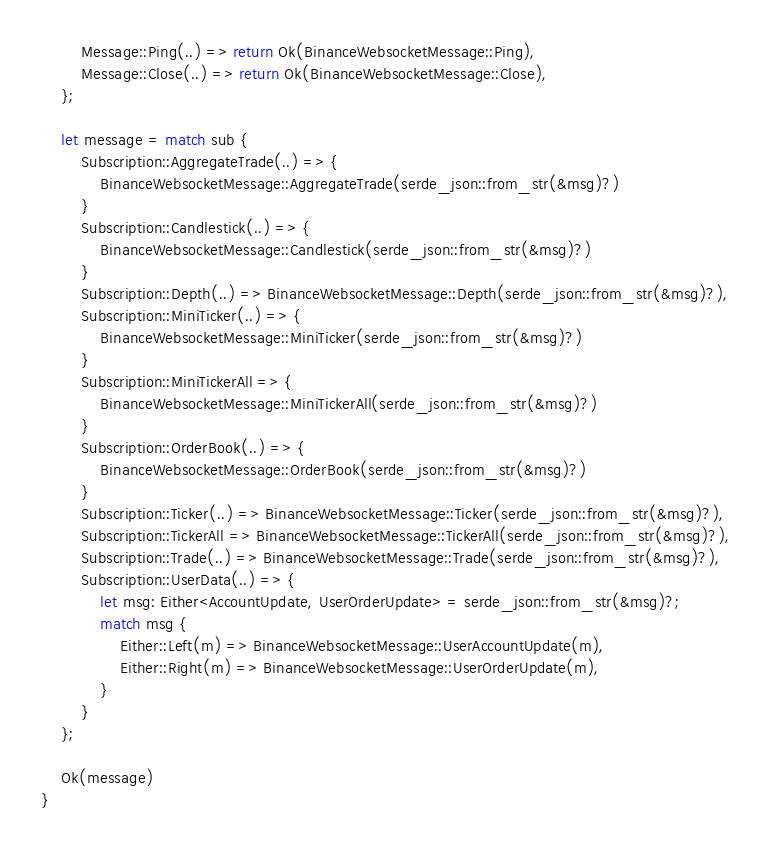Convert code to text. <code><loc_0><loc_0><loc_500><loc_500><_Rust_>        Message::Ping(..) => return Ok(BinanceWebsocketMessage::Ping),
        Message::Close(..) => return Ok(BinanceWebsocketMessage::Close),
    };

    let message = match sub {
        Subscription::AggregateTrade(..) => {
            BinanceWebsocketMessage::AggregateTrade(serde_json::from_str(&msg)?)
        }
        Subscription::Candlestick(..) => {
            BinanceWebsocketMessage::Candlestick(serde_json::from_str(&msg)?)
        }
        Subscription::Depth(..) => BinanceWebsocketMessage::Depth(serde_json::from_str(&msg)?),
        Subscription::MiniTicker(..) => {
            BinanceWebsocketMessage::MiniTicker(serde_json::from_str(&msg)?)
        }
        Subscription::MiniTickerAll => {
            BinanceWebsocketMessage::MiniTickerAll(serde_json::from_str(&msg)?)
        }
        Subscription::OrderBook(..) => {
            BinanceWebsocketMessage::OrderBook(serde_json::from_str(&msg)?)
        }
        Subscription::Ticker(..) => BinanceWebsocketMessage::Ticker(serde_json::from_str(&msg)?),
        Subscription::TickerAll => BinanceWebsocketMessage::TickerAll(serde_json::from_str(&msg)?),
        Subscription::Trade(..) => BinanceWebsocketMessage::Trade(serde_json::from_str(&msg)?),
        Subscription::UserData(..) => {
            let msg: Either<AccountUpdate, UserOrderUpdate> = serde_json::from_str(&msg)?;
            match msg {
                Either::Left(m) => BinanceWebsocketMessage::UserAccountUpdate(m),
                Either::Right(m) => BinanceWebsocketMessage::UserOrderUpdate(m),
            }
        }
    };

    Ok(message)
}
</code> 